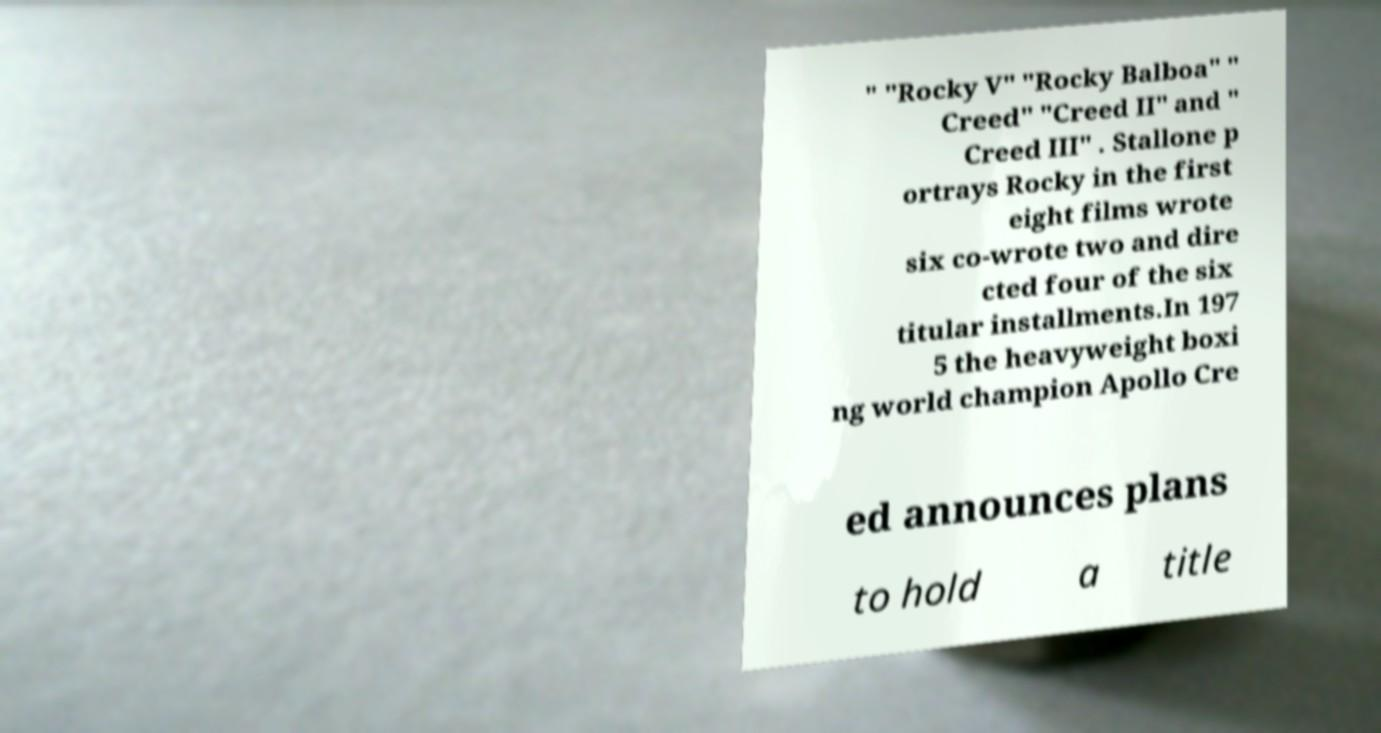I need the written content from this picture converted into text. Can you do that? " "Rocky V" "Rocky Balboa" " Creed" "Creed II" and " Creed III" . Stallone p ortrays Rocky in the first eight films wrote six co-wrote two and dire cted four of the six titular installments.In 197 5 the heavyweight boxi ng world champion Apollo Cre ed announces plans to hold a title 